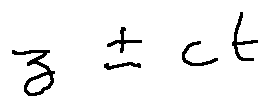<formula> <loc_0><loc_0><loc_500><loc_500>z \pm c t</formula> 